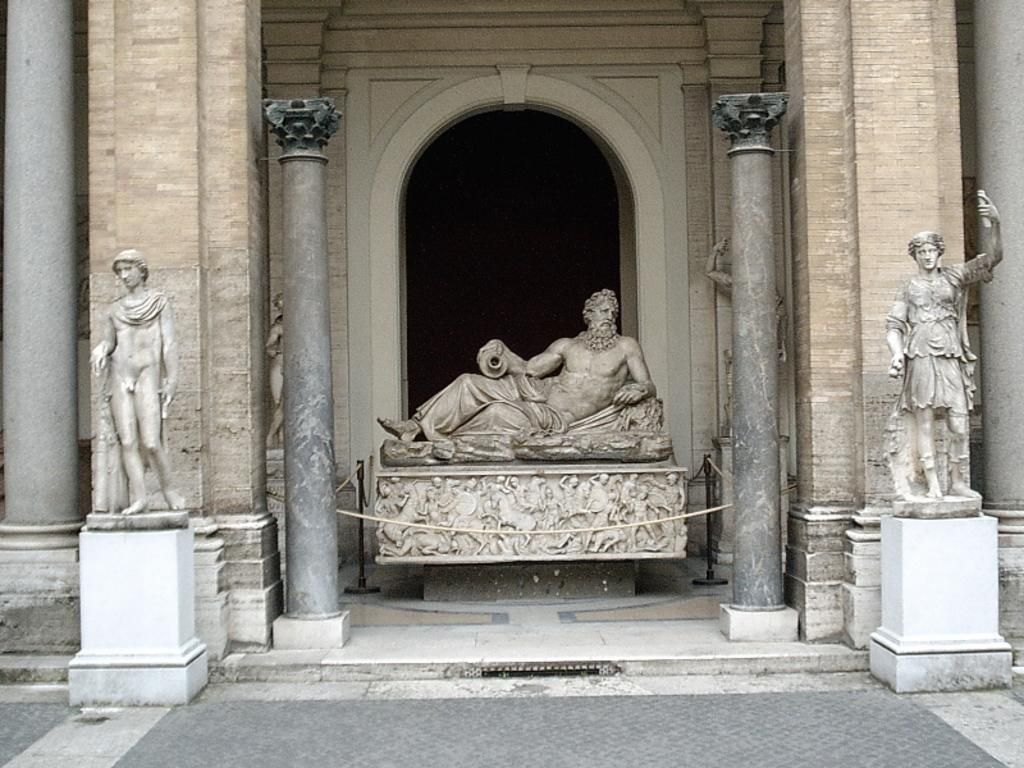What type of artwork can be seen in the image? There are sculptures in the image. What architectural features are present in the image? There are pillars inars in the image. What structure is visible in the background of the image? There is a wall in the image. How many rabbits can be seen wearing dresses in the image? There are no rabbits or dresses present in the image. 